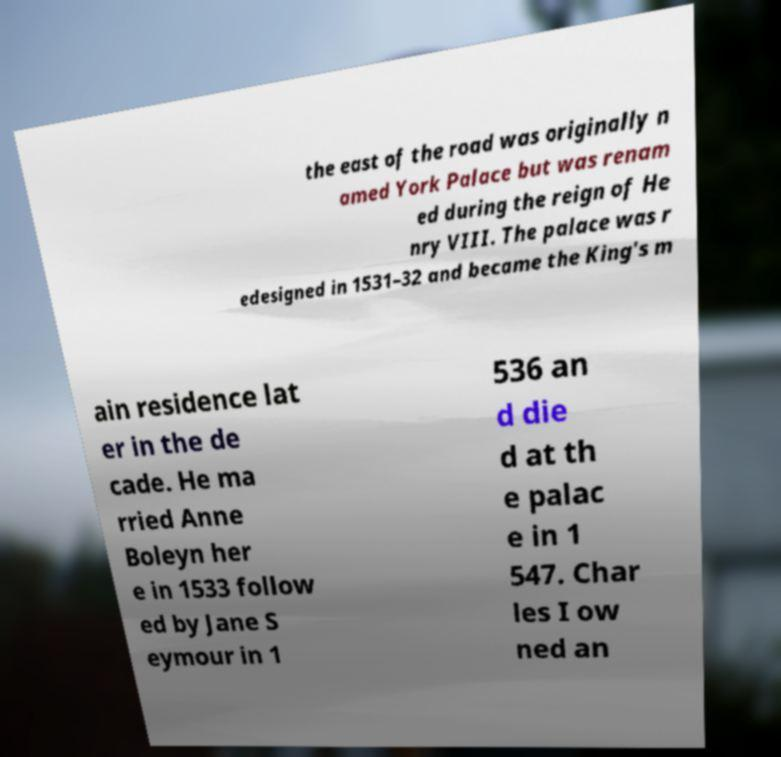Please read and relay the text visible in this image. What does it say? the east of the road was originally n amed York Palace but was renam ed during the reign of He nry VIII. The palace was r edesigned in 1531–32 and became the King's m ain residence lat er in the de cade. He ma rried Anne Boleyn her e in 1533 follow ed by Jane S eymour in 1 536 an d die d at th e palac e in 1 547. Char les I ow ned an 